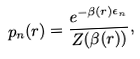Convert formula to latex. <formula><loc_0><loc_0><loc_500><loc_500>p _ { n } ( r ) = \frac { e ^ { - \beta ( r ) \epsilon _ { n } } } { Z ( \beta ( r ) ) } ,</formula> 